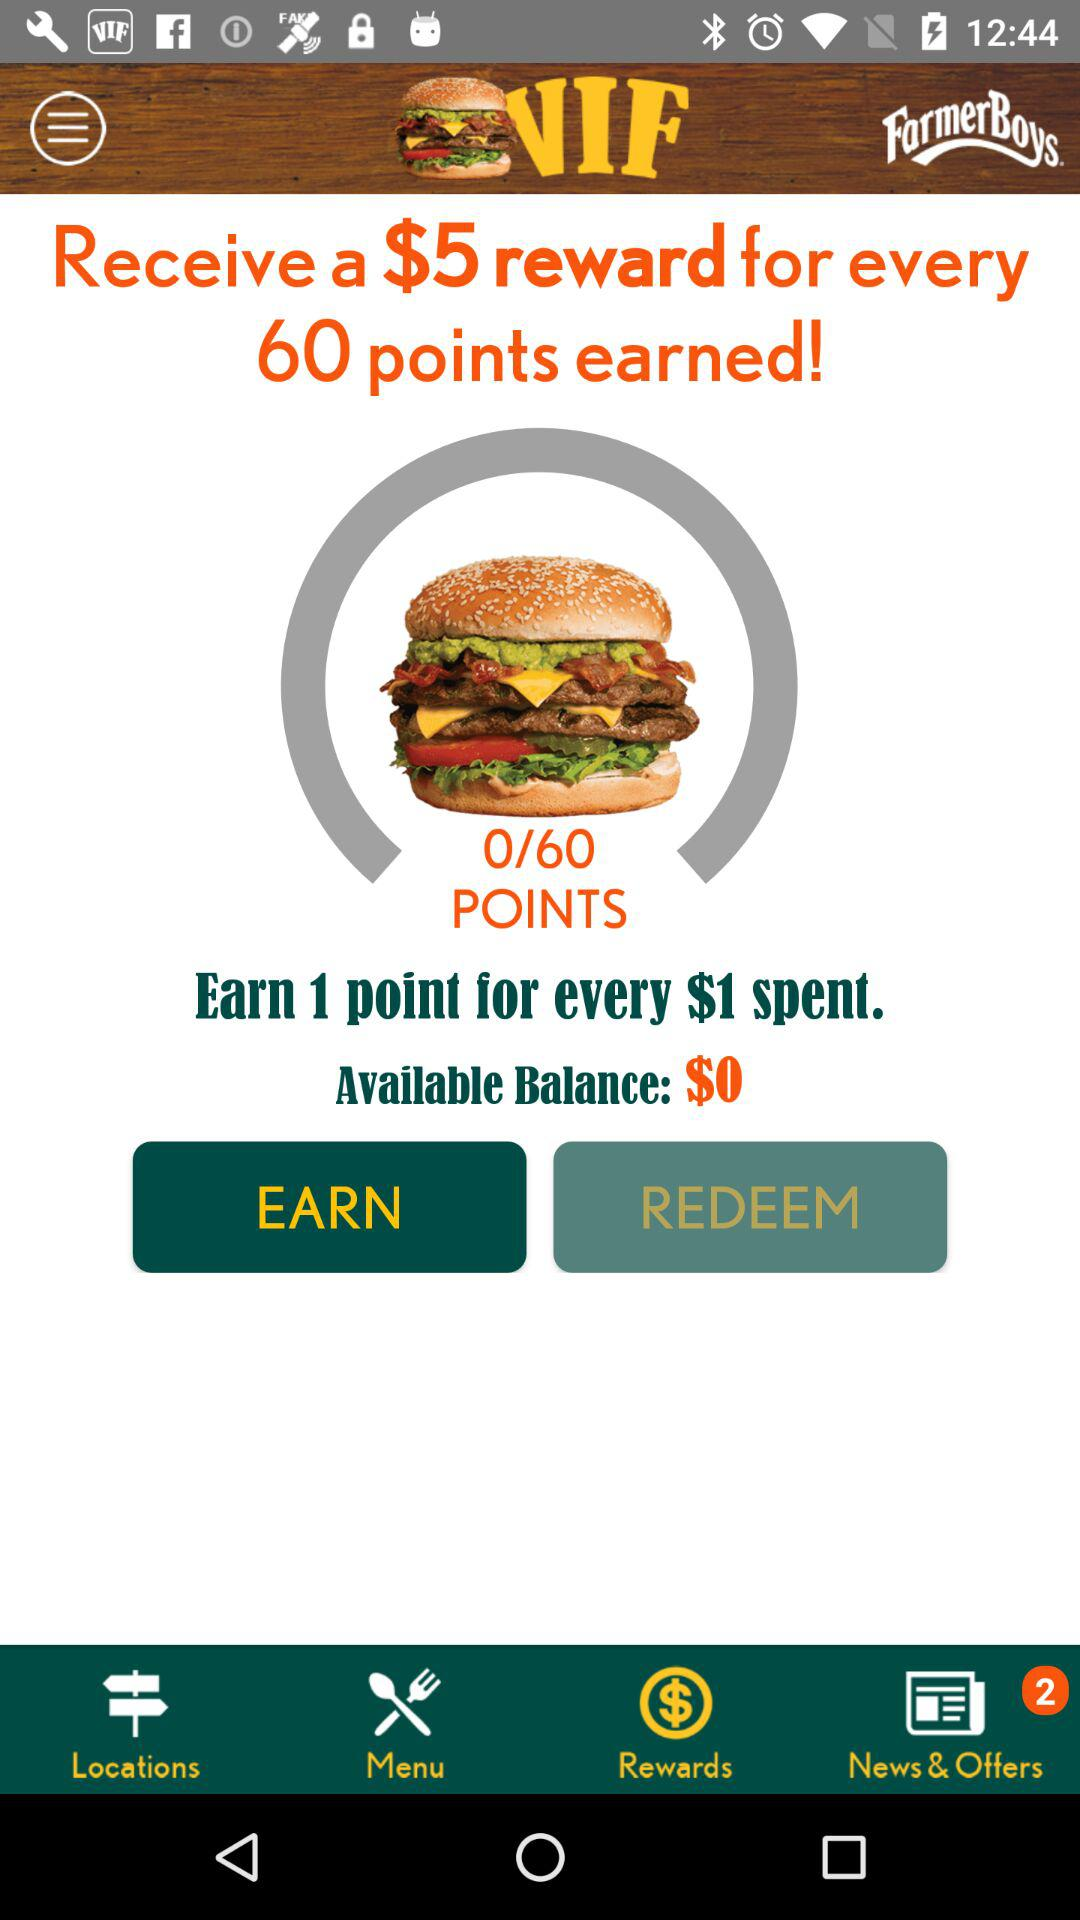What is the total number of points? The total number of points is 60. 